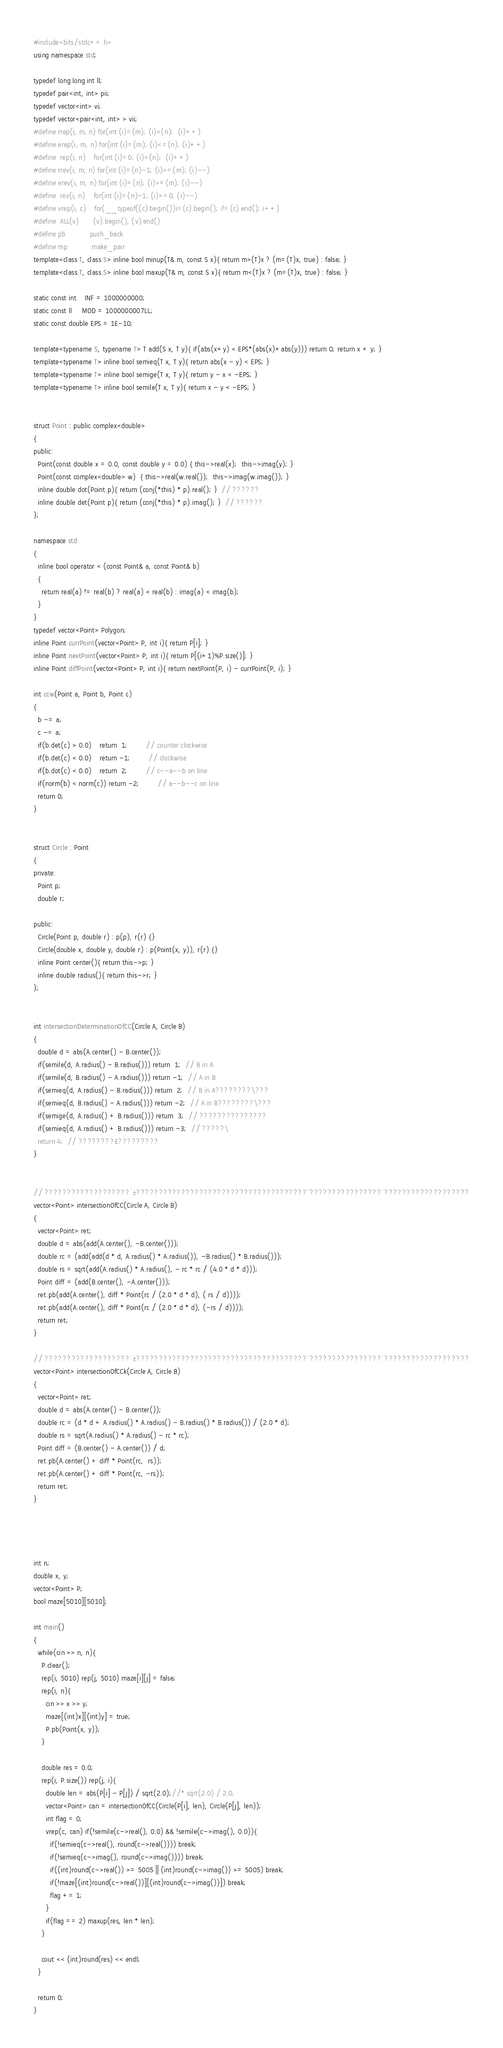<code> <loc_0><loc_0><loc_500><loc_500><_C++_>#include<bits/stdc++.h>
using namespace std;

typedef long long int ll;
typedef pair<int, int> pii;
typedef vector<int> vi;
typedef vector<pair<int, int> > vii;
#define rrep(i, m, n) for(int (i)=(m); (i)<(n);  (i)++)
#define erep(i, m, n) for(int (i)=(m); (i)<=(n); (i)++)
#define  rep(i, n)    for(int (i)=0; (i)<(n);  (i)++)
#define rrev(i, m, n) for(int (i)=(n)-1; (i)>=(m); (i)--)
#define erev(i, m, n) for(int (i)=(n); (i)>=(m); (i)--)
#define  rev(i, n)    for(int (i)=(n)-1; (i)>=0; (i)--)
#define vrep(i, c)    for(__typeof((c).begin())i=(c).begin(); i!=(c).end(); i++)
#define  ALL(v)       (v).begin(), (v).end()
#define pb            push_back
#define mp            make_pair
template<class T, class S> inline bool minup(T& m, const S x){ return m>(T)x ? (m=(T)x, true) : false; }
template<class T, class S> inline bool maxup(T& m, const S x){ return m<(T)x ? (m=(T)x, true) : false; }

static const int    INF = 1000000000;
static const ll     MOD = 1000000007LL;
static const double EPS = 1E-10;

template<typename S, typename T> T add(S x, T y){ if(abs(x+y) < EPS*(abs(x)+abs(y))) return 0; return x + y; }
template<typename T> inline bool semieq(T x, T y){ return abs(x - y) < EPS; }
template<typename T> inline bool semige(T x, T y){ return y - x < -EPS; }
template<typename T> inline bool semile(T x, T y){ return x - y < -EPS; }


struct Point : public complex<double>
{
public:
  Point(const double x = 0.0, const double y = 0.0) { this->real(x);  this->imag(y); }
  Point(const complex<double> w)  { this->real(w.real());  this->imag(w.imag()); }
  inline double dot(Point p){ return (conj(*this) * p).real(); }  // ??????
  inline double det(Point p){ return (conj(*this) * p).imag(); }  // ??????
};

namespace std
{
  inline bool operator < (const Point& a, const Point& b)
  {
    return real(a) != real(b) ? real(a) < real(b) : imag(a) < imag(b);
  }
}
typedef vector<Point> Polygon;
inline Point currPoint(vector<Point> P, int i){ return P[i]; }
inline Point nextPoint(vector<Point> P, int i){ return P[(i+1)%P.size()]; }
inline Point diffPoint(vector<Point> P, int i){ return nextPoint(P, i) - currPoint(P, i); }

int ccw(Point a, Point b, Point c)
{
  b -= a;
  c -= a;
  if(b.det(c) > 0.0)    return  1;         // counter clockwise
  if(b.det(c) < 0.0)    return -1;         // clockwise
  if(b.dot(c) < 0.0)    return  2;         // c--a--b on line
  if(norm(b) < norm(c)) return -2;         // a--b--c on line
  return 0;
}


struct Circle : Point
{
private:
  Point p;
  double r;

public:
  Circle(Point p, double r) : p(p), r(r) {}
  Circle(double x, double y, double r) : p(Point(x, y)), r(r) {}
  inline Point center(){ return this->p; }
  inline double radius(){ return this->r; }
};


int intersectionDeterminationOfCC(Circle A, Circle B)
{
  double d = abs(A.center() - B.center());
  if(semile(d, A.radius() - B.radius())) return  1;  // B in A
  if(semile(d, B.radius() - A.radius())) return -1;  // A in B
  if(semieq(d, A.radius() - B.radius())) return  2;  // B in A????????\???
  if(semieq(d, B.radius() - A.radius())) return -2;  // A in B????????\???
  if(semige(d, A.radius() + B.radius())) return  3;  // ???????????????
  if(semieq(d, A.radius() + B.radius())) return -3;  // ?????\
  return 4;  // ????????£?????????
}


// ???????????????????¨±??????????????????????????????????????¨????????????????¨???????????????????
vector<Point> intersectionOfCC(Circle A, Circle B)
{
  vector<Point> ret;
  double d = abs(add(A.center(), -B.center()));
  double rc = (add(add(d * d, A.radius() * A.radius()), -B.radius() * B.radius()));
  double rs = sqrt(add(A.radius() * A.radius(), - rc * rc / (4.0 * d * d)));
  Point diff = (add(B.center(), -A.center()));
  ret.pb(add(A.center(), diff * Point(rc / (2.0 * d * d), ( rs / d))));
  ret.pb(add(A.center(), diff * Point(rc / (2.0 * d * d), (-rs / d))));
  return ret;
}

// ???????????????????¨±??????????????????????????????????????¨????????????????¨???????????????????
vector<Point> intersectionOfCCk(Circle A, Circle B)
{
  vector<Point> ret;
  double d = abs(A.center() - B.center());
  double rc = (d * d + A.radius() * A.radius() - B.radius() * B.radius()) / (2.0 * d);
  double rs = sqrt(A.radius() * A.radius() - rc * rc);
  Point diff = (B.center() - A.center()) / d;
  ret.pb(A.center() + diff * Point(rc,  rs));
  ret.pb(A.center() + diff * Point(rc, -rs));
  return ret;
}




int n;
double x, y;
vector<Point> P;
bool maze[5010][5010];

int main()
{
  while(cin >> n, n){
    P.clear();
    rep(i, 5010) rep(j, 5010) maze[i][j] = false;
    rep(i, n){
      cin >> x >> y;
      maze[(int)x][(int)y] = true;
      P.pb(Point(x, y));
    }

    double res = 0.0;
    rep(i, P.size()) rep(j, i){
      double len = abs(P[i] - P[j]) / sqrt(2.0);//* sqrt(2.0) / 2.0;
      vector<Point> can = intersectionOfCC(Circle(P[i], len), Circle(P[j], len));
      int flag = 0;
      vrep(c, can) if(!semile(c->real(), 0.0) && !semile(c->imag(), 0.0)){
        if(!semieq(c->real(), round(c->real()))) break;
        if(!semieq(c->imag(), round(c->imag()))) break;
        if((int)round(c->real()) >= 5005 || (int)round(c->imag()) >= 5005) break;
        if(!maze[(int)round(c->real())][(int)round(c->imag())]) break;
        flag += 1;
      }
      if(flag == 2) maxup(res, len * len);
    }

    cout << (int)round(res) << endl;
  }

  return 0;
}</code> 